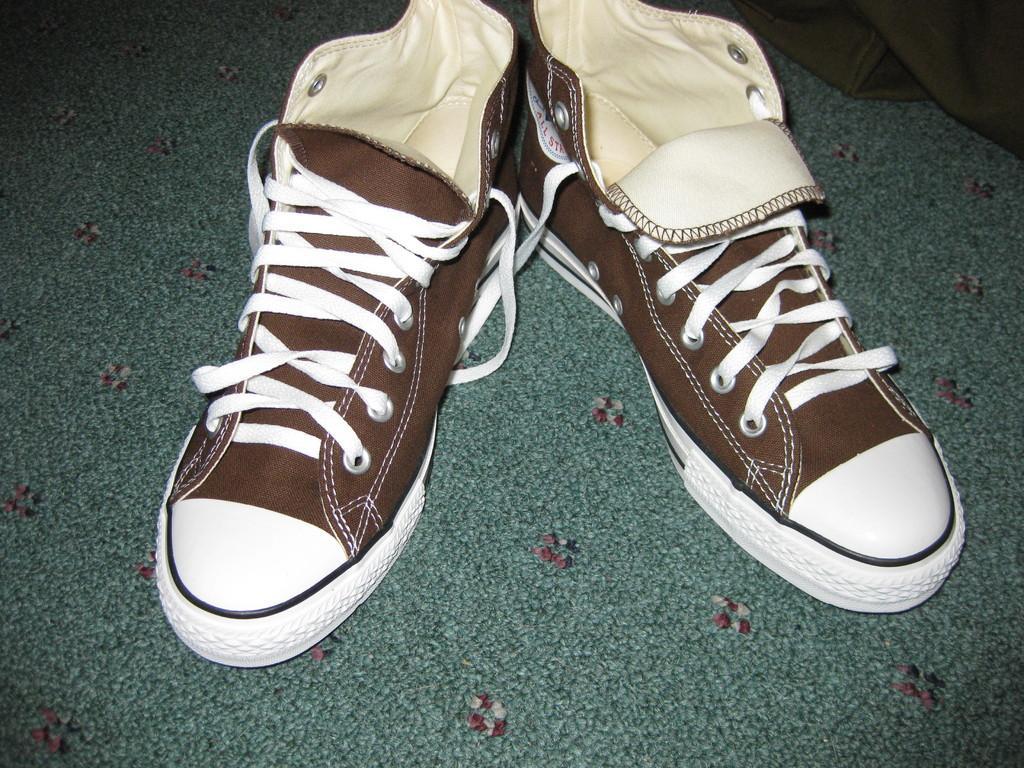Could you give a brief overview of what you see in this image? In this picture there are brown color shoes on the floor. At the bottom there is a green color mat. In the top right there is a green color cloth. 